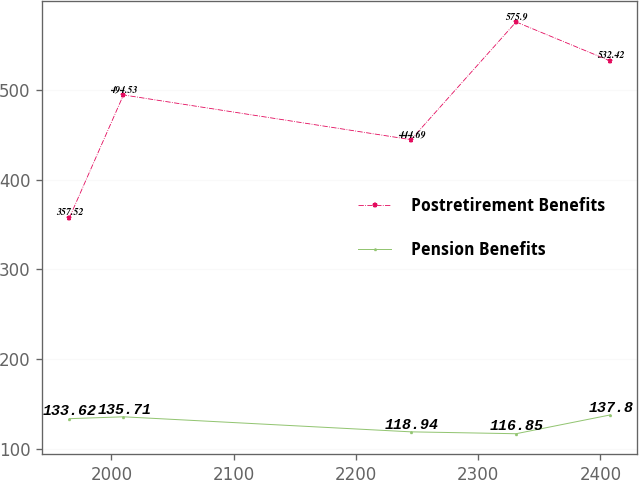Convert chart to OTSL. <chart><loc_0><loc_0><loc_500><loc_500><line_chart><ecel><fcel>Postretirement Benefits<fcel>Pension Benefits<nl><fcel>1965.63<fcel>357.52<fcel>133.62<nl><fcel>2009.87<fcel>494.53<fcel>135.71<nl><fcel>2245.06<fcel>444.69<fcel>118.94<nl><fcel>2330.98<fcel>575.9<fcel>116.85<nl><fcel>2407.98<fcel>532.42<fcel>137.8<nl></chart> 